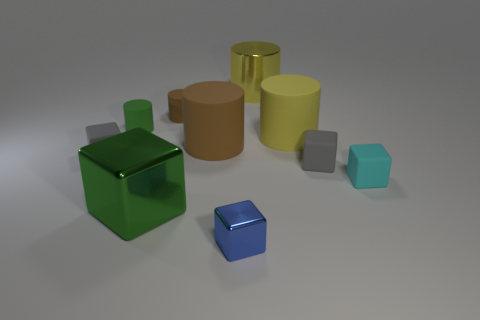Subtract all green cylinders. How many cylinders are left? 4 Subtract all yellow metal cylinders. How many cylinders are left? 4 Subtract all brown blocks. Subtract all blue spheres. How many blocks are left? 5 Subtract all gray things. Subtract all shiny blocks. How many objects are left? 6 Add 6 tiny blocks. How many tiny blocks are left? 10 Add 1 big shiny things. How many big shiny things exist? 3 Subtract 0 yellow balls. How many objects are left? 10 